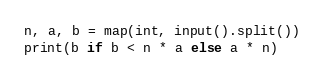Convert code to text. <code><loc_0><loc_0><loc_500><loc_500><_Python_>n, a, b = map(int, input().split())
print(b if b < n * a else a * n)
</code> 